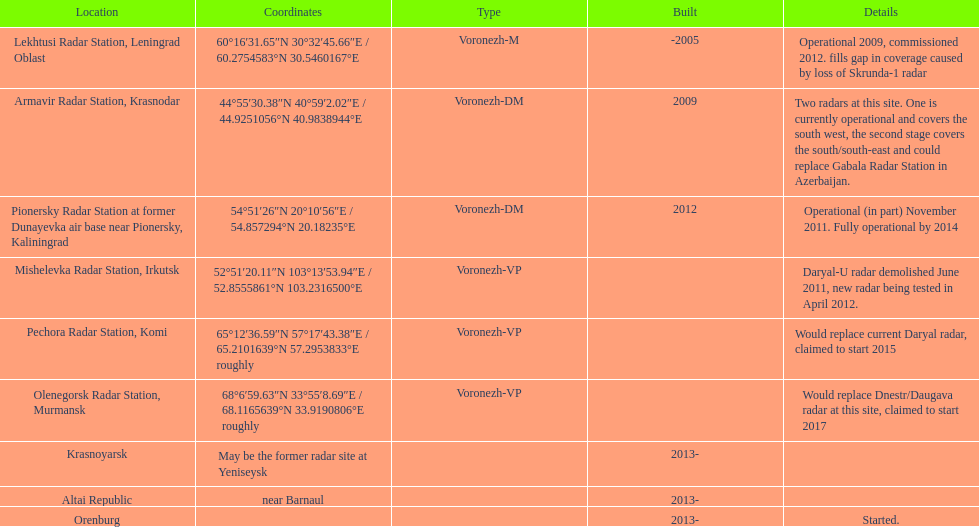What are the locations of the voronezh radar? Lekhtusi Radar Station, Leningrad Oblast, Armavir Radar Station, Krasnodar, Pionersky Radar Station at former Dunayevka air base near Pionersky, Kaliningrad, Mishelevka Radar Station, Irkutsk, Pechora Radar Station, Komi, Olenegorsk Radar Station, Murmansk, Krasnoyarsk, Altai Republic, Orenburg. Which locations have identifiable coordinates? Lekhtusi Radar Station, Leningrad Oblast, Armavir Radar Station, Krasnodar, Pionersky Radar Station at former Dunayevka air base near Pionersky, Kaliningrad, Mishelevka Radar Station, Irkutsk, Pechora Radar Station, Komi, Olenegorsk Radar Station, Murmansk. Which specific location has the coordinates 60°16'31.65"n 30°32'45.66"e / 60.2754583°n 30.5460167°e? Lekhtusi Radar Station, Leningrad Oblast. 